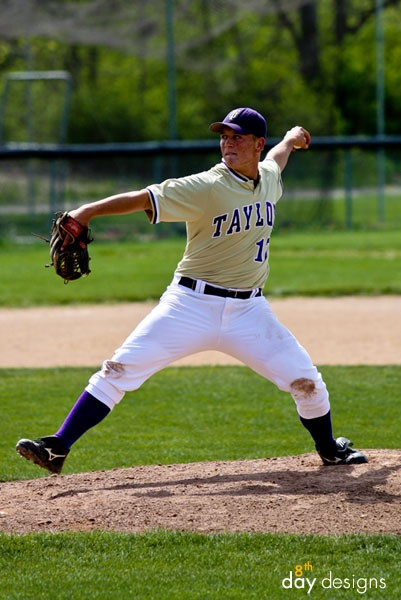Describe the objects in this image and their specific colors. I can see people in black, lavender, darkgray, and gray tones, baseball glove in black, maroon, darkgreen, and olive tones, sports ball in black, tan, brown, and gray tones, and sports ball in black, maroon, gray, and brown tones in this image. 